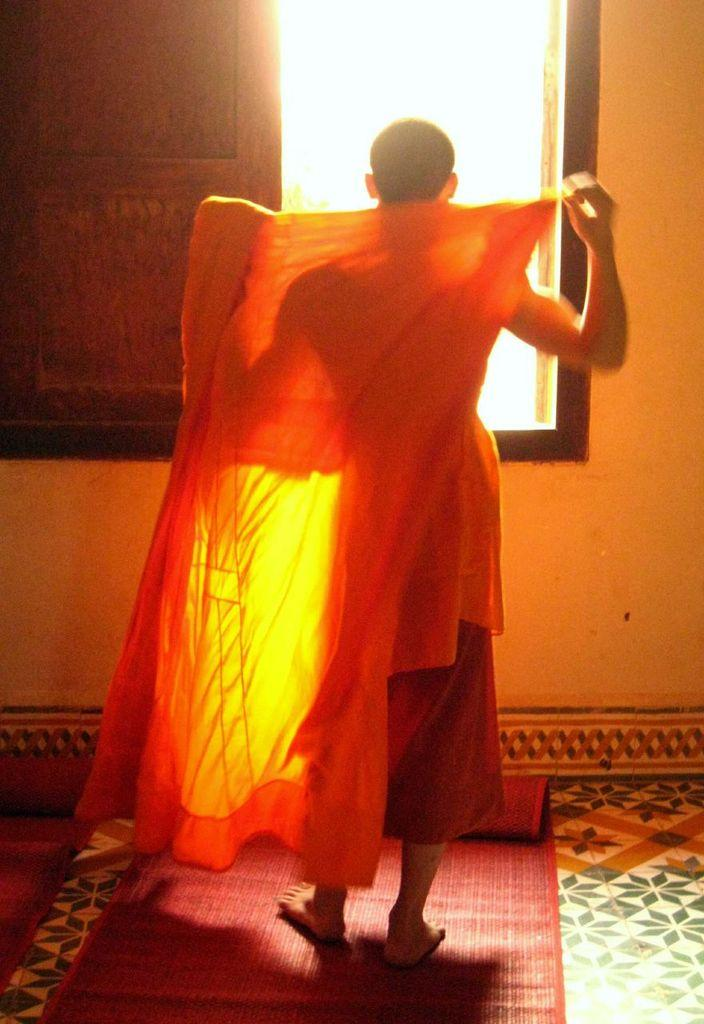Who or what is present in the image? There is a person in the image. What is the person holding in the image? The person is holding a cloth. What is the person standing or sitting on in the image? The person is on a mat. What can be seen through the window in the image? The image does not show what can be seen through the window. What is visible on the wall in the image? The image does not specify what is visible on the wall. What type of key is the person using to unlock the tent in the image? There is no tent or key present in the image. What color is the sweater the person is wearing in the image? The image does not mention the person wearing a sweater. 